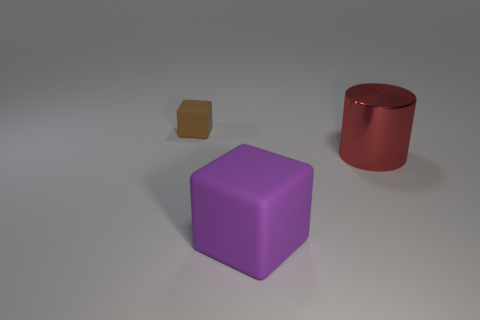Add 3 big brown shiny cubes. How many objects exist? 6 Subtract all brown blocks. How many blocks are left? 1 Subtract all blue cylinders. How many green cubes are left? 0 Subtract all cubes. How many objects are left? 1 Subtract all green matte cubes. Subtract all large purple objects. How many objects are left? 2 Add 1 big red cylinders. How many big red cylinders are left? 2 Add 3 metallic cylinders. How many metallic cylinders exist? 4 Subtract 1 purple cubes. How many objects are left? 2 Subtract all purple cylinders. Subtract all yellow spheres. How many cylinders are left? 1 